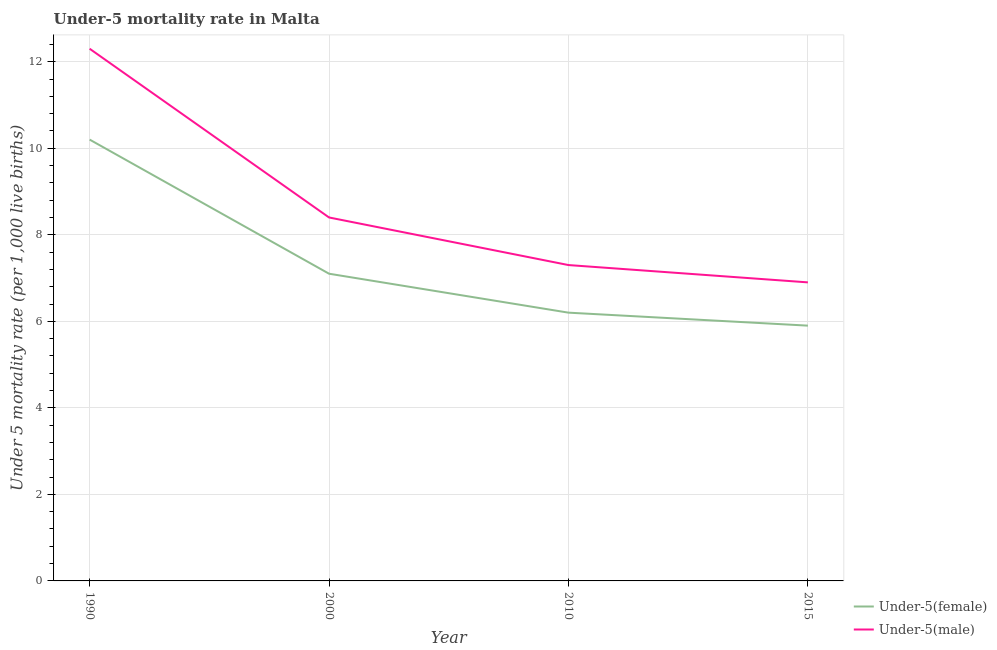What is the under-5 male mortality rate in 2015?
Your answer should be compact. 6.9. Across all years, what is the minimum under-5 male mortality rate?
Make the answer very short. 6.9. In which year was the under-5 male mortality rate minimum?
Ensure brevity in your answer.  2015. What is the total under-5 male mortality rate in the graph?
Offer a terse response. 34.9. What is the difference between the under-5 male mortality rate in 2000 and that in 2010?
Your answer should be compact. 1.1. What is the average under-5 female mortality rate per year?
Your answer should be compact. 7.35. In the year 2010, what is the difference between the under-5 male mortality rate and under-5 female mortality rate?
Provide a short and direct response. 1.1. In how many years, is the under-5 female mortality rate greater than 4?
Your answer should be compact. 4. What is the ratio of the under-5 female mortality rate in 1990 to that in 2010?
Offer a very short reply. 1.65. Is the under-5 female mortality rate in 1990 less than that in 2015?
Provide a succinct answer. No. What is the difference between the highest and the second highest under-5 female mortality rate?
Provide a succinct answer. 3.1. What is the difference between the highest and the lowest under-5 female mortality rate?
Offer a very short reply. 4.3. In how many years, is the under-5 female mortality rate greater than the average under-5 female mortality rate taken over all years?
Provide a succinct answer. 1. Does the under-5 female mortality rate monotonically increase over the years?
Offer a terse response. No. Is the under-5 female mortality rate strictly less than the under-5 male mortality rate over the years?
Your answer should be very brief. Yes. How many lines are there?
Your answer should be compact. 2. What is the difference between two consecutive major ticks on the Y-axis?
Provide a short and direct response. 2. Are the values on the major ticks of Y-axis written in scientific E-notation?
Offer a very short reply. No. How many legend labels are there?
Your answer should be compact. 2. What is the title of the graph?
Give a very brief answer. Under-5 mortality rate in Malta. What is the label or title of the Y-axis?
Offer a terse response. Under 5 mortality rate (per 1,0 live births). What is the Under 5 mortality rate (per 1,000 live births) of Under-5(male) in 1990?
Your answer should be very brief. 12.3. What is the Under 5 mortality rate (per 1,000 live births) in Under-5(female) in 2000?
Offer a terse response. 7.1. What is the Under 5 mortality rate (per 1,000 live births) in Under-5(male) in 2010?
Give a very brief answer. 7.3. Across all years, what is the maximum Under 5 mortality rate (per 1,000 live births) in Under-5(female)?
Provide a succinct answer. 10.2. Across all years, what is the minimum Under 5 mortality rate (per 1,000 live births) of Under-5(male)?
Keep it short and to the point. 6.9. What is the total Under 5 mortality rate (per 1,000 live births) of Under-5(female) in the graph?
Your response must be concise. 29.4. What is the total Under 5 mortality rate (per 1,000 live births) in Under-5(male) in the graph?
Make the answer very short. 34.9. What is the difference between the Under 5 mortality rate (per 1,000 live births) in Under-5(male) in 1990 and that in 2010?
Give a very brief answer. 5. What is the difference between the Under 5 mortality rate (per 1,000 live births) in Under-5(female) in 1990 and that in 2015?
Ensure brevity in your answer.  4.3. What is the difference between the Under 5 mortality rate (per 1,000 live births) in Under-5(male) in 1990 and that in 2015?
Your answer should be compact. 5.4. What is the difference between the Under 5 mortality rate (per 1,000 live births) in Under-5(female) in 2000 and that in 2015?
Your answer should be compact. 1.2. What is the difference between the Under 5 mortality rate (per 1,000 live births) of Under-5(male) in 2000 and that in 2015?
Your answer should be compact. 1.5. What is the difference between the Under 5 mortality rate (per 1,000 live births) of Under-5(female) in 1990 and the Under 5 mortality rate (per 1,000 live births) of Under-5(male) in 2000?
Provide a succinct answer. 1.8. What is the difference between the Under 5 mortality rate (per 1,000 live births) in Under-5(female) in 1990 and the Under 5 mortality rate (per 1,000 live births) in Under-5(male) in 2010?
Your answer should be compact. 2.9. What is the difference between the Under 5 mortality rate (per 1,000 live births) of Under-5(female) in 1990 and the Under 5 mortality rate (per 1,000 live births) of Under-5(male) in 2015?
Your answer should be very brief. 3.3. What is the difference between the Under 5 mortality rate (per 1,000 live births) of Under-5(female) in 2000 and the Under 5 mortality rate (per 1,000 live births) of Under-5(male) in 2015?
Offer a very short reply. 0.2. What is the difference between the Under 5 mortality rate (per 1,000 live births) in Under-5(female) in 2010 and the Under 5 mortality rate (per 1,000 live births) in Under-5(male) in 2015?
Make the answer very short. -0.7. What is the average Under 5 mortality rate (per 1,000 live births) in Under-5(female) per year?
Your answer should be very brief. 7.35. What is the average Under 5 mortality rate (per 1,000 live births) in Under-5(male) per year?
Your answer should be very brief. 8.72. In the year 1990, what is the difference between the Under 5 mortality rate (per 1,000 live births) in Under-5(female) and Under 5 mortality rate (per 1,000 live births) in Under-5(male)?
Give a very brief answer. -2.1. In the year 2015, what is the difference between the Under 5 mortality rate (per 1,000 live births) of Under-5(female) and Under 5 mortality rate (per 1,000 live births) of Under-5(male)?
Give a very brief answer. -1. What is the ratio of the Under 5 mortality rate (per 1,000 live births) in Under-5(female) in 1990 to that in 2000?
Offer a terse response. 1.44. What is the ratio of the Under 5 mortality rate (per 1,000 live births) of Under-5(male) in 1990 to that in 2000?
Ensure brevity in your answer.  1.46. What is the ratio of the Under 5 mortality rate (per 1,000 live births) in Under-5(female) in 1990 to that in 2010?
Your response must be concise. 1.65. What is the ratio of the Under 5 mortality rate (per 1,000 live births) in Under-5(male) in 1990 to that in 2010?
Offer a terse response. 1.68. What is the ratio of the Under 5 mortality rate (per 1,000 live births) of Under-5(female) in 1990 to that in 2015?
Provide a succinct answer. 1.73. What is the ratio of the Under 5 mortality rate (per 1,000 live births) in Under-5(male) in 1990 to that in 2015?
Ensure brevity in your answer.  1.78. What is the ratio of the Under 5 mortality rate (per 1,000 live births) in Under-5(female) in 2000 to that in 2010?
Offer a very short reply. 1.15. What is the ratio of the Under 5 mortality rate (per 1,000 live births) of Under-5(male) in 2000 to that in 2010?
Your answer should be very brief. 1.15. What is the ratio of the Under 5 mortality rate (per 1,000 live births) of Under-5(female) in 2000 to that in 2015?
Make the answer very short. 1.2. What is the ratio of the Under 5 mortality rate (per 1,000 live births) of Under-5(male) in 2000 to that in 2015?
Your answer should be compact. 1.22. What is the ratio of the Under 5 mortality rate (per 1,000 live births) of Under-5(female) in 2010 to that in 2015?
Your answer should be very brief. 1.05. What is the ratio of the Under 5 mortality rate (per 1,000 live births) of Under-5(male) in 2010 to that in 2015?
Offer a very short reply. 1.06. What is the difference between the highest and the second highest Under 5 mortality rate (per 1,000 live births) in Under-5(female)?
Give a very brief answer. 3.1. What is the difference between the highest and the lowest Under 5 mortality rate (per 1,000 live births) of Under-5(male)?
Your response must be concise. 5.4. 